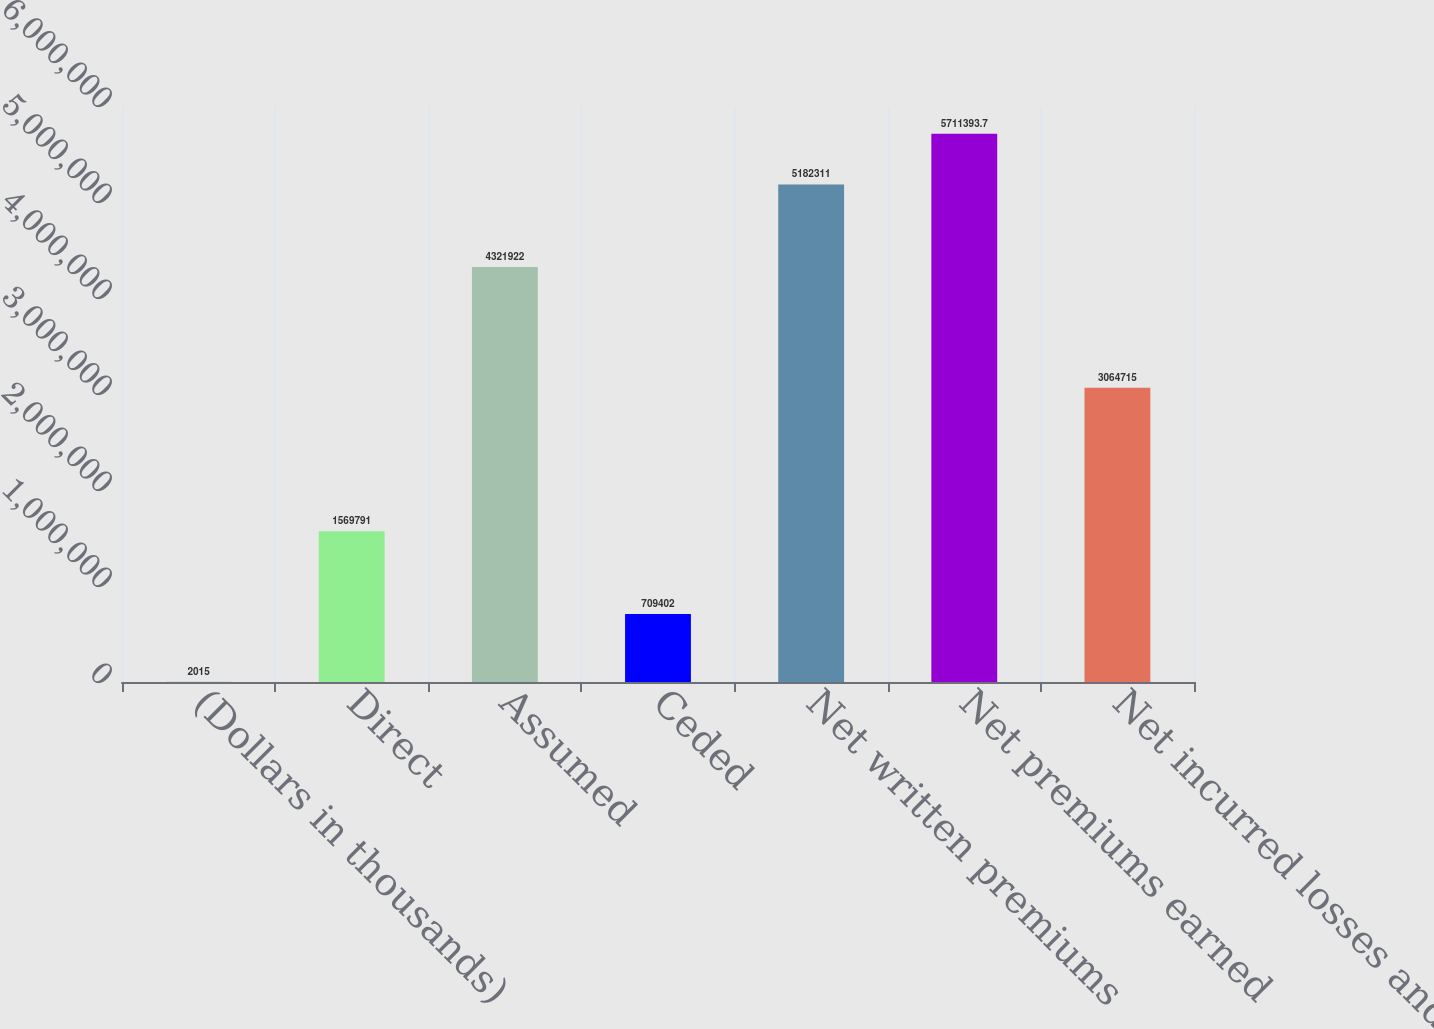Convert chart to OTSL. <chart><loc_0><loc_0><loc_500><loc_500><bar_chart><fcel>(Dollars in thousands)<fcel>Direct<fcel>Assumed<fcel>Ceded<fcel>Net written premiums<fcel>Net premiums earned<fcel>Net incurred losses and LAE<nl><fcel>2015<fcel>1.56979e+06<fcel>4.32192e+06<fcel>709402<fcel>5.18231e+06<fcel>5.71139e+06<fcel>3.06472e+06<nl></chart> 